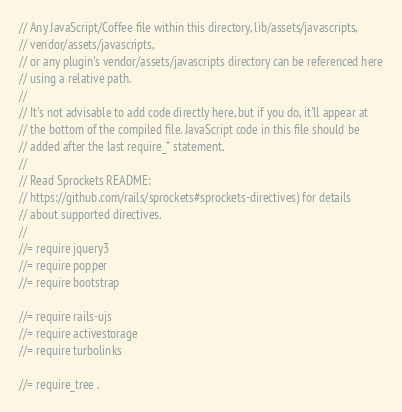<code> <loc_0><loc_0><loc_500><loc_500><_JavaScript_>// Any JavaScript/Coffee file within this directory, lib/assets/javascripts,
// vendor/assets/javascripts,
// or any plugin's vendor/assets/javascripts directory can be referenced here
// using a relative path.
//
// It's not advisable to add code directly here, but if you do, it'll appear at
// the bottom of the compiled file. JavaScript code in this file should be
// added after the last require_* statement.
//
// Read Sprockets README:
// https://github.com/rails/sprockets#sprockets-directives) for details
// about supported directives.
//
//= require jquery3
//= require popper
//= require bootstrap

//= require rails-ujs
//= require activestorage
//= require turbolinks

//= require_tree .

</code> 